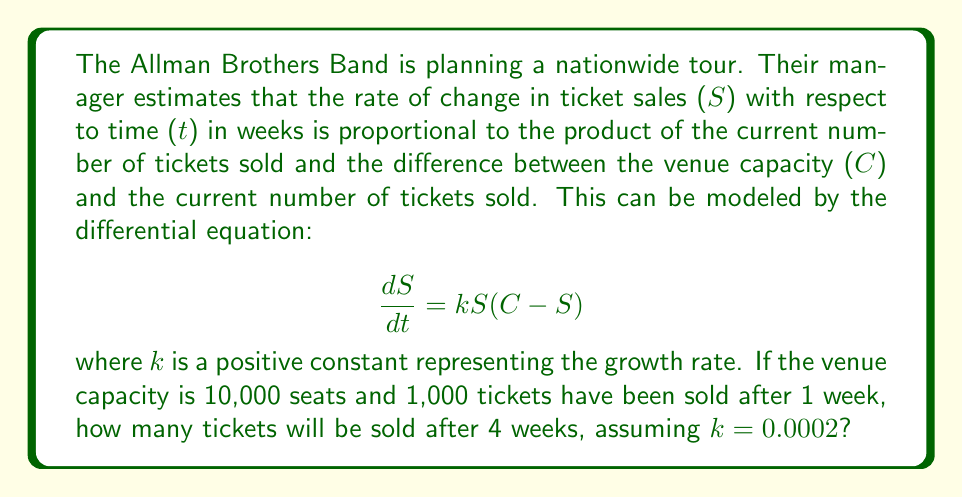Help me with this question. To solve this problem, we need to use the logistic growth model, which is represented by the given differential equation. Let's approach this step-by-step:

1) The general solution to the logistic equation is:

   $$S(t) = \frac{C}{1 + Ae^{-kCt}}$$

   where A is a constant that depends on the initial conditions.

2) We're given that C = 10,000 and k = 0.0002. We need to find A using the initial condition: S(1) = 1,000.

3) Substituting these values into the general solution:

   $$1000 = \frac{10000}{1 + Ae^{-0.0002 * 10000 * 1}}$$

4) Solving for A:

   $$A = (\frac{10000}{1000} - 1)e^{2} \approx 20.085536$$

5) Now we have the specific solution:

   $$S(t) = \frac{10000}{1 + 20.085536e^{-2t}}$$

6) To find the number of tickets sold after 4 weeks, we calculate S(4):

   $$S(4) = \frac{10000}{1 + 20.085536e^{-2*4}}$$

7) Evaluating this expression:

   $$S(4) \approx 3,706$$

Therefore, after 4 weeks, approximately 3,706 tickets will be sold.
Answer: Approximately 3,706 tickets will be sold after 4 weeks. 